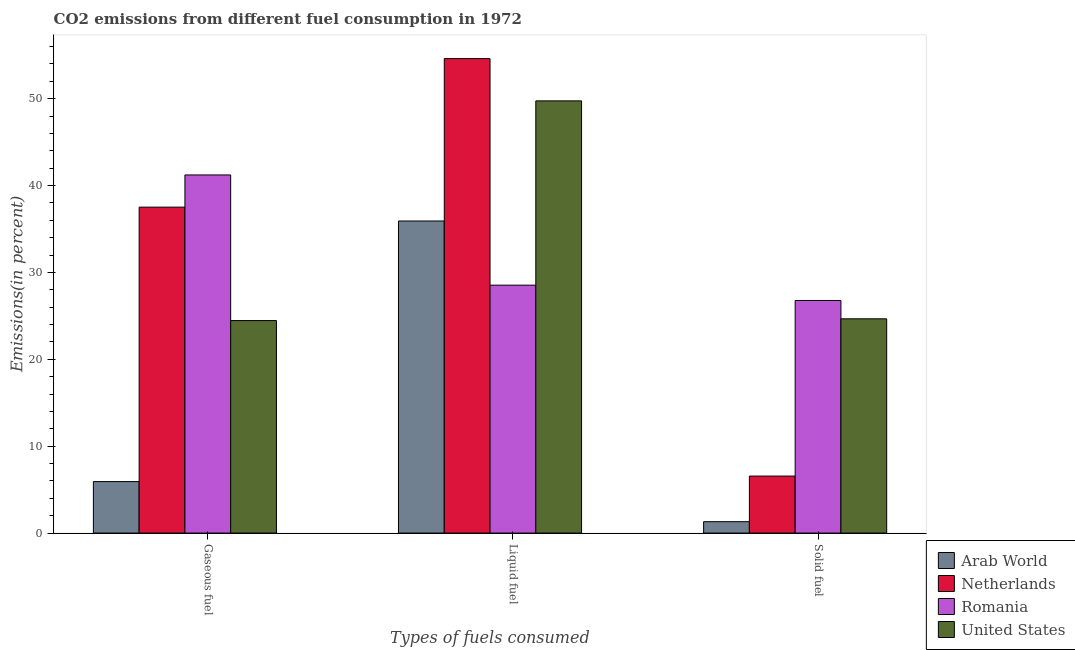How many different coloured bars are there?
Your answer should be compact. 4. How many groups of bars are there?
Provide a short and direct response. 3. Are the number of bars on each tick of the X-axis equal?
Your response must be concise. Yes. How many bars are there on the 2nd tick from the right?
Your answer should be compact. 4. What is the label of the 3rd group of bars from the left?
Offer a very short reply. Solid fuel. What is the percentage of gaseous fuel emission in United States?
Ensure brevity in your answer.  24.46. Across all countries, what is the maximum percentage of gaseous fuel emission?
Provide a succinct answer. 41.22. Across all countries, what is the minimum percentage of solid fuel emission?
Ensure brevity in your answer.  1.31. In which country was the percentage of gaseous fuel emission maximum?
Provide a short and direct response. Romania. In which country was the percentage of liquid fuel emission minimum?
Your answer should be very brief. Romania. What is the total percentage of gaseous fuel emission in the graph?
Keep it short and to the point. 109.12. What is the difference between the percentage of gaseous fuel emission in United States and that in Arab World?
Your response must be concise. 18.53. What is the difference between the percentage of liquid fuel emission in Arab World and the percentage of gaseous fuel emission in United States?
Your answer should be compact. 11.46. What is the average percentage of liquid fuel emission per country?
Ensure brevity in your answer.  42.21. What is the difference between the percentage of liquid fuel emission and percentage of gaseous fuel emission in Romania?
Your answer should be very brief. -12.69. In how many countries, is the percentage of liquid fuel emission greater than 22 %?
Give a very brief answer. 4. What is the ratio of the percentage of solid fuel emission in Arab World to that in Netherlands?
Ensure brevity in your answer.  0.2. Is the difference between the percentage of solid fuel emission in Netherlands and Romania greater than the difference between the percentage of liquid fuel emission in Netherlands and Romania?
Offer a terse response. No. What is the difference between the highest and the second highest percentage of solid fuel emission?
Provide a succinct answer. 2.11. What is the difference between the highest and the lowest percentage of gaseous fuel emission?
Offer a terse response. 35.3. In how many countries, is the percentage of liquid fuel emission greater than the average percentage of liquid fuel emission taken over all countries?
Provide a short and direct response. 2. Is the sum of the percentage of liquid fuel emission in United States and Romania greater than the maximum percentage of gaseous fuel emission across all countries?
Ensure brevity in your answer.  Yes. What does the 3rd bar from the left in Liquid fuel represents?
Provide a short and direct response. Romania. How many bars are there?
Make the answer very short. 12. Are all the bars in the graph horizontal?
Give a very brief answer. No. How many countries are there in the graph?
Give a very brief answer. 4. Where does the legend appear in the graph?
Your answer should be compact. Bottom right. What is the title of the graph?
Your response must be concise. CO2 emissions from different fuel consumption in 1972. What is the label or title of the X-axis?
Ensure brevity in your answer.  Types of fuels consumed. What is the label or title of the Y-axis?
Offer a very short reply. Emissions(in percent). What is the Emissions(in percent) of Arab World in Gaseous fuel?
Keep it short and to the point. 5.93. What is the Emissions(in percent) in Netherlands in Gaseous fuel?
Make the answer very short. 37.52. What is the Emissions(in percent) of Romania in Gaseous fuel?
Offer a terse response. 41.22. What is the Emissions(in percent) in United States in Gaseous fuel?
Give a very brief answer. 24.46. What is the Emissions(in percent) in Arab World in Liquid fuel?
Your answer should be very brief. 35.92. What is the Emissions(in percent) of Netherlands in Liquid fuel?
Ensure brevity in your answer.  54.61. What is the Emissions(in percent) of Romania in Liquid fuel?
Your answer should be very brief. 28.54. What is the Emissions(in percent) in United States in Liquid fuel?
Give a very brief answer. 49.75. What is the Emissions(in percent) in Arab World in Solid fuel?
Your answer should be very brief. 1.31. What is the Emissions(in percent) of Netherlands in Solid fuel?
Your answer should be very brief. 6.56. What is the Emissions(in percent) of Romania in Solid fuel?
Ensure brevity in your answer.  26.77. What is the Emissions(in percent) in United States in Solid fuel?
Your answer should be very brief. 24.66. Across all Types of fuels consumed, what is the maximum Emissions(in percent) of Arab World?
Ensure brevity in your answer.  35.92. Across all Types of fuels consumed, what is the maximum Emissions(in percent) in Netherlands?
Offer a terse response. 54.61. Across all Types of fuels consumed, what is the maximum Emissions(in percent) in Romania?
Offer a terse response. 41.22. Across all Types of fuels consumed, what is the maximum Emissions(in percent) in United States?
Offer a terse response. 49.75. Across all Types of fuels consumed, what is the minimum Emissions(in percent) of Arab World?
Your response must be concise. 1.31. Across all Types of fuels consumed, what is the minimum Emissions(in percent) of Netherlands?
Keep it short and to the point. 6.56. Across all Types of fuels consumed, what is the minimum Emissions(in percent) of Romania?
Provide a short and direct response. 26.77. Across all Types of fuels consumed, what is the minimum Emissions(in percent) in United States?
Your answer should be compact. 24.46. What is the total Emissions(in percent) of Arab World in the graph?
Your answer should be very brief. 43.16. What is the total Emissions(in percent) of Netherlands in the graph?
Your answer should be compact. 98.69. What is the total Emissions(in percent) of Romania in the graph?
Offer a terse response. 96.53. What is the total Emissions(in percent) of United States in the graph?
Your answer should be very brief. 98.87. What is the difference between the Emissions(in percent) in Arab World in Gaseous fuel and that in Liquid fuel?
Ensure brevity in your answer.  -30. What is the difference between the Emissions(in percent) of Netherlands in Gaseous fuel and that in Liquid fuel?
Provide a succinct answer. -17.1. What is the difference between the Emissions(in percent) of Romania in Gaseous fuel and that in Liquid fuel?
Your answer should be compact. 12.69. What is the difference between the Emissions(in percent) in United States in Gaseous fuel and that in Liquid fuel?
Give a very brief answer. -25.29. What is the difference between the Emissions(in percent) in Arab World in Gaseous fuel and that in Solid fuel?
Offer a terse response. 4.61. What is the difference between the Emissions(in percent) in Netherlands in Gaseous fuel and that in Solid fuel?
Provide a succinct answer. 30.96. What is the difference between the Emissions(in percent) in Romania in Gaseous fuel and that in Solid fuel?
Make the answer very short. 14.45. What is the difference between the Emissions(in percent) of United States in Gaseous fuel and that in Solid fuel?
Make the answer very short. -0.2. What is the difference between the Emissions(in percent) of Arab World in Liquid fuel and that in Solid fuel?
Your answer should be compact. 34.61. What is the difference between the Emissions(in percent) in Netherlands in Liquid fuel and that in Solid fuel?
Your answer should be very brief. 48.05. What is the difference between the Emissions(in percent) in Romania in Liquid fuel and that in Solid fuel?
Provide a short and direct response. 1.76. What is the difference between the Emissions(in percent) in United States in Liquid fuel and that in Solid fuel?
Keep it short and to the point. 25.09. What is the difference between the Emissions(in percent) of Arab World in Gaseous fuel and the Emissions(in percent) of Netherlands in Liquid fuel?
Offer a very short reply. -48.69. What is the difference between the Emissions(in percent) in Arab World in Gaseous fuel and the Emissions(in percent) in Romania in Liquid fuel?
Ensure brevity in your answer.  -22.61. What is the difference between the Emissions(in percent) of Arab World in Gaseous fuel and the Emissions(in percent) of United States in Liquid fuel?
Provide a short and direct response. -43.82. What is the difference between the Emissions(in percent) of Netherlands in Gaseous fuel and the Emissions(in percent) of Romania in Liquid fuel?
Provide a short and direct response. 8.98. What is the difference between the Emissions(in percent) of Netherlands in Gaseous fuel and the Emissions(in percent) of United States in Liquid fuel?
Your response must be concise. -12.23. What is the difference between the Emissions(in percent) in Romania in Gaseous fuel and the Emissions(in percent) in United States in Liquid fuel?
Your response must be concise. -8.53. What is the difference between the Emissions(in percent) in Arab World in Gaseous fuel and the Emissions(in percent) in Netherlands in Solid fuel?
Ensure brevity in your answer.  -0.64. What is the difference between the Emissions(in percent) in Arab World in Gaseous fuel and the Emissions(in percent) in Romania in Solid fuel?
Give a very brief answer. -20.85. What is the difference between the Emissions(in percent) in Arab World in Gaseous fuel and the Emissions(in percent) in United States in Solid fuel?
Make the answer very short. -18.74. What is the difference between the Emissions(in percent) in Netherlands in Gaseous fuel and the Emissions(in percent) in Romania in Solid fuel?
Your response must be concise. 10.74. What is the difference between the Emissions(in percent) of Netherlands in Gaseous fuel and the Emissions(in percent) of United States in Solid fuel?
Your answer should be compact. 12.86. What is the difference between the Emissions(in percent) of Romania in Gaseous fuel and the Emissions(in percent) of United States in Solid fuel?
Offer a very short reply. 16.56. What is the difference between the Emissions(in percent) of Arab World in Liquid fuel and the Emissions(in percent) of Netherlands in Solid fuel?
Make the answer very short. 29.36. What is the difference between the Emissions(in percent) of Arab World in Liquid fuel and the Emissions(in percent) of Romania in Solid fuel?
Make the answer very short. 9.15. What is the difference between the Emissions(in percent) in Arab World in Liquid fuel and the Emissions(in percent) in United States in Solid fuel?
Your answer should be compact. 11.26. What is the difference between the Emissions(in percent) of Netherlands in Liquid fuel and the Emissions(in percent) of Romania in Solid fuel?
Offer a very short reply. 27.84. What is the difference between the Emissions(in percent) of Netherlands in Liquid fuel and the Emissions(in percent) of United States in Solid fuel?
Offer a very short reply. 29.95. What is the difference between the Emissions(in percent) in Romania in Liquid fuel and the Emissions(in percent) in United States in Solid fuel?
Your answer should be very brief. 3.88. What is the average Emissions(in percent) in Arab World per Types of fuels consumed?
Give a very brief answer. 14.39. What is the average Emissions(in percent) of Netherlands per Types of fuels consumed?
Make the answer very short. 32.9. What is the average Emissions(in percent) of Romania per Types of fuels consumed?
Ensure brevity in your answer.  32.18. What is the average Emissions(in percent) in United States per Types of fuels consumed?
Keep it short and to the point. 32.96. What is the difference between the Emissions(in percent) in Arab World and Emissions(in percent) in Netherlands in Gaseous fuel?
Ensure brevity in your answer.  -31.59. What is the difference between the Emissions(in percent) in Arab World and Emissions(in percent) in Romania in Gaseous fuel?
Provide a short and direct response. -35.3. What is the difference between the Emissions(in percent) of Arab World and Emissions(in percent) of United States in Gaseous fuel?
Your answer should be compact. -18.53. What is the difference between the Emissions(in percent) in Netherlands and Emissions(in percent) in Romania in Gaseous fuel?
Offer a very short reply. -3.7. What is the difference between the Emissions(in percent) in Netherlands and Emissions(in percent) in United States in Gaseous fuel?
Give a very brief answer. 13.06. What is the difference between the Emissions(in percent) in Romania and Emissions(in percent) in United States in Gaseous fuel?
Offer a very short reply. 16.76. What is the difference between the Emissions(in percent) in Arab World and Emissions(in percent) in Netherlands in Liquid fuel?
Make the answer very short. -18.69. What is the difference between the Emissions(in percent) in Arab World and Emissions(in percent) in Romania in Liquid fuel?
Give a very brief answer. 7.39. What is the difference between the Emissions(in percent) of Arab World and Emissions(in percent) of United States in Liquid fuel?
Make the answer very short. -13.83. What is the difference between the Emissions(in percent) in Netherlands and Emissions(in percent) in Romania in Liquid fuel?
Provide a short and direct response. 26.08. What is the difference between the Emissions(in percent) of Netherlands and Emissions(in percent) of United States in Liquid fuel?
Provide a succinct answer. 4.86. What is the difference between the Emissions(in percent) of Romania and Emissions(in percent) of United States in Liquid fuel?
Give a very brief answer. -21.21. What is the difference between the Emissions(in percent) in Arab World and Emissions(in percent) in Netherlands in Solid fuel?
Provide a succinct answer. -5.25. What is the difference between the Emissions(in percent) of Arab World and Emissions(in percent) of Romania in Solid fuel?
Keep it short and to the point. -25.46. What is the difference between the Emissions(in percent) in Arab World and Emissions(in percent) in United States in Solid fuel?
Offer a terse response. -23.35. What is the difference between the Emissions(in percent) in Netherlands and Emissions(in percent) in Romania in Solid fuel?
Make the answer very short. -20.21. What is the difference between the Emissions(in percent) in Netherlands and Emissions(in percent) in United States in Solid fuel?
Offer a very short reply. -18.1. What is the difference between the Emissions(in percent) in Romania and Emissions(in percent) in United States in Solid fuel?
Your answer should be very brief. 2.11. What is the ratio of the Emissions(in percent) of Arab World in Gaseous fuel to that in Liquid fuel?
Provide a short and direct response. 0.17. What is the ratio of the Emissions(in percent) of Netherlands in Gaseous fuel to that in Liquid fuel?
Make the answer very short. 0.69. What is the ratio of the Emissions(in percent) of Romania in Gaseous fuel to that in Liquid fuel?
Offer a very short reply. 1.44. What is the ratio of the Emissions(in percent) in United States in Gaseous fuel to that in Liquid fuel?
Offer a very short reply. 0.49. What is the ratio of the Emissions(in percent) of Arab World in Gaseous fuel to that in Solid fuel?
Ensure brevity in your answer.  4.52. What is the ratio of the Emissions(in percent) of Netherlands in Gaseous fuel to that in Solid fuel?
Give a very brief answer. 5.72. What is the ratio of the Emissions(in percent) in Romania in Gaseous fuel to that in Solid fuel?
Ensure brevity in your answer.  1.54. What is the ratio of the Emissions(in percent) in Arab World in Liquid fuel to that in Solid fuel?
Your answer should be very brief. 27.39. What is the ratio of the Emissions(in percent) of Netherlands in Liquid fuel to that in Solid fuel?
Provide a succinct answer. 8.32. What is the ratio of the Emissions(in percent) in Romania in Liquid fuel to that in Solid fuel?
Offer a terse response. 1.07. What is the ratio of the Emissions(in percent) in United States in Liquid fuel to that in Solid fuel?
Your answer should be compact. 2.02. What is the difference between the highest and the second highest Emissions(in percent) of Arab World?
Your answer should be very brief. 30. What is the difference between the highest and the second highest Emissions(in percent) in Netherlands?
Provide a succinct answer. 17.1. What is the difference between the highest and the second highest Emissions(in percent) in Romania?
Your answer should be very brief. 12.69. What is the difference between the highest and the second highest Emissions(in percent) in United States?
Offer a very short reply. 25.09. What is the difference between the highest and the lowest Emissions(in percent) of Arab World?
Offer a very short reply. 34.61. What is the difference between the highest and the lowest Emissions(in percent) of Netherlands?
Provide a succinct answer. 48.05. What is the difference between the highest and the lowest Emissions(in percent) in Romania?
Keep it short and to the point. 14.45. What is the difference between the highest and the lowest Emissions(in percent) of United States?
Provide a short and direct response. 25.29. 